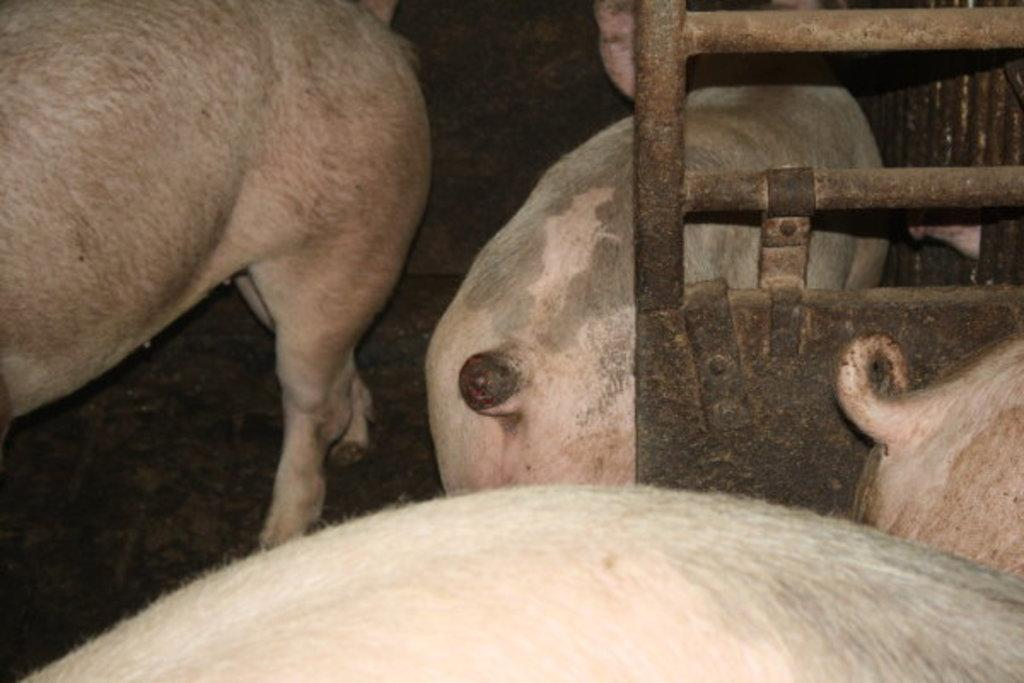What type of animals are in the image? There is a group of pigs in the image. Where are the pigs located in the image? The pigs are in a sty. What type of blood can be seen on the pigs in the image? There is no blood visible on the pigs in the image. How far away is the insect from the pigs in the image? There is no insect present in the image. 